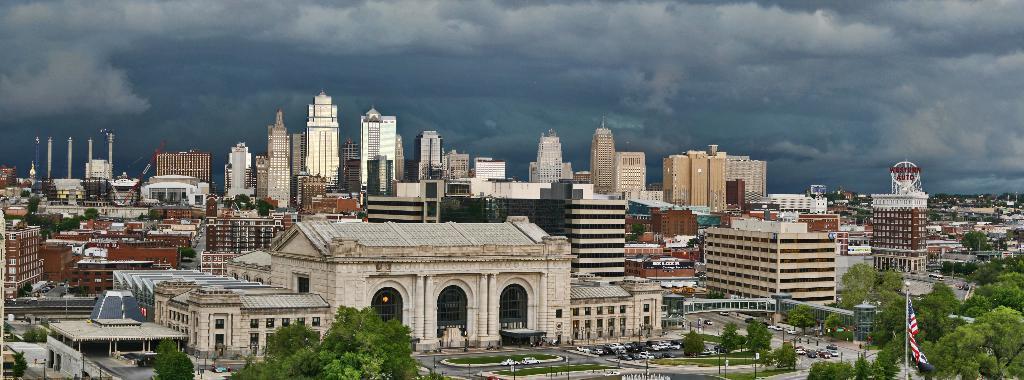Please provide a concise description of this image. In the image in the center we can see buildings,trees,plants,grass,poles,vehicles,banners,pillars,road,flag etc. In the background we can see the sky and clouds. 